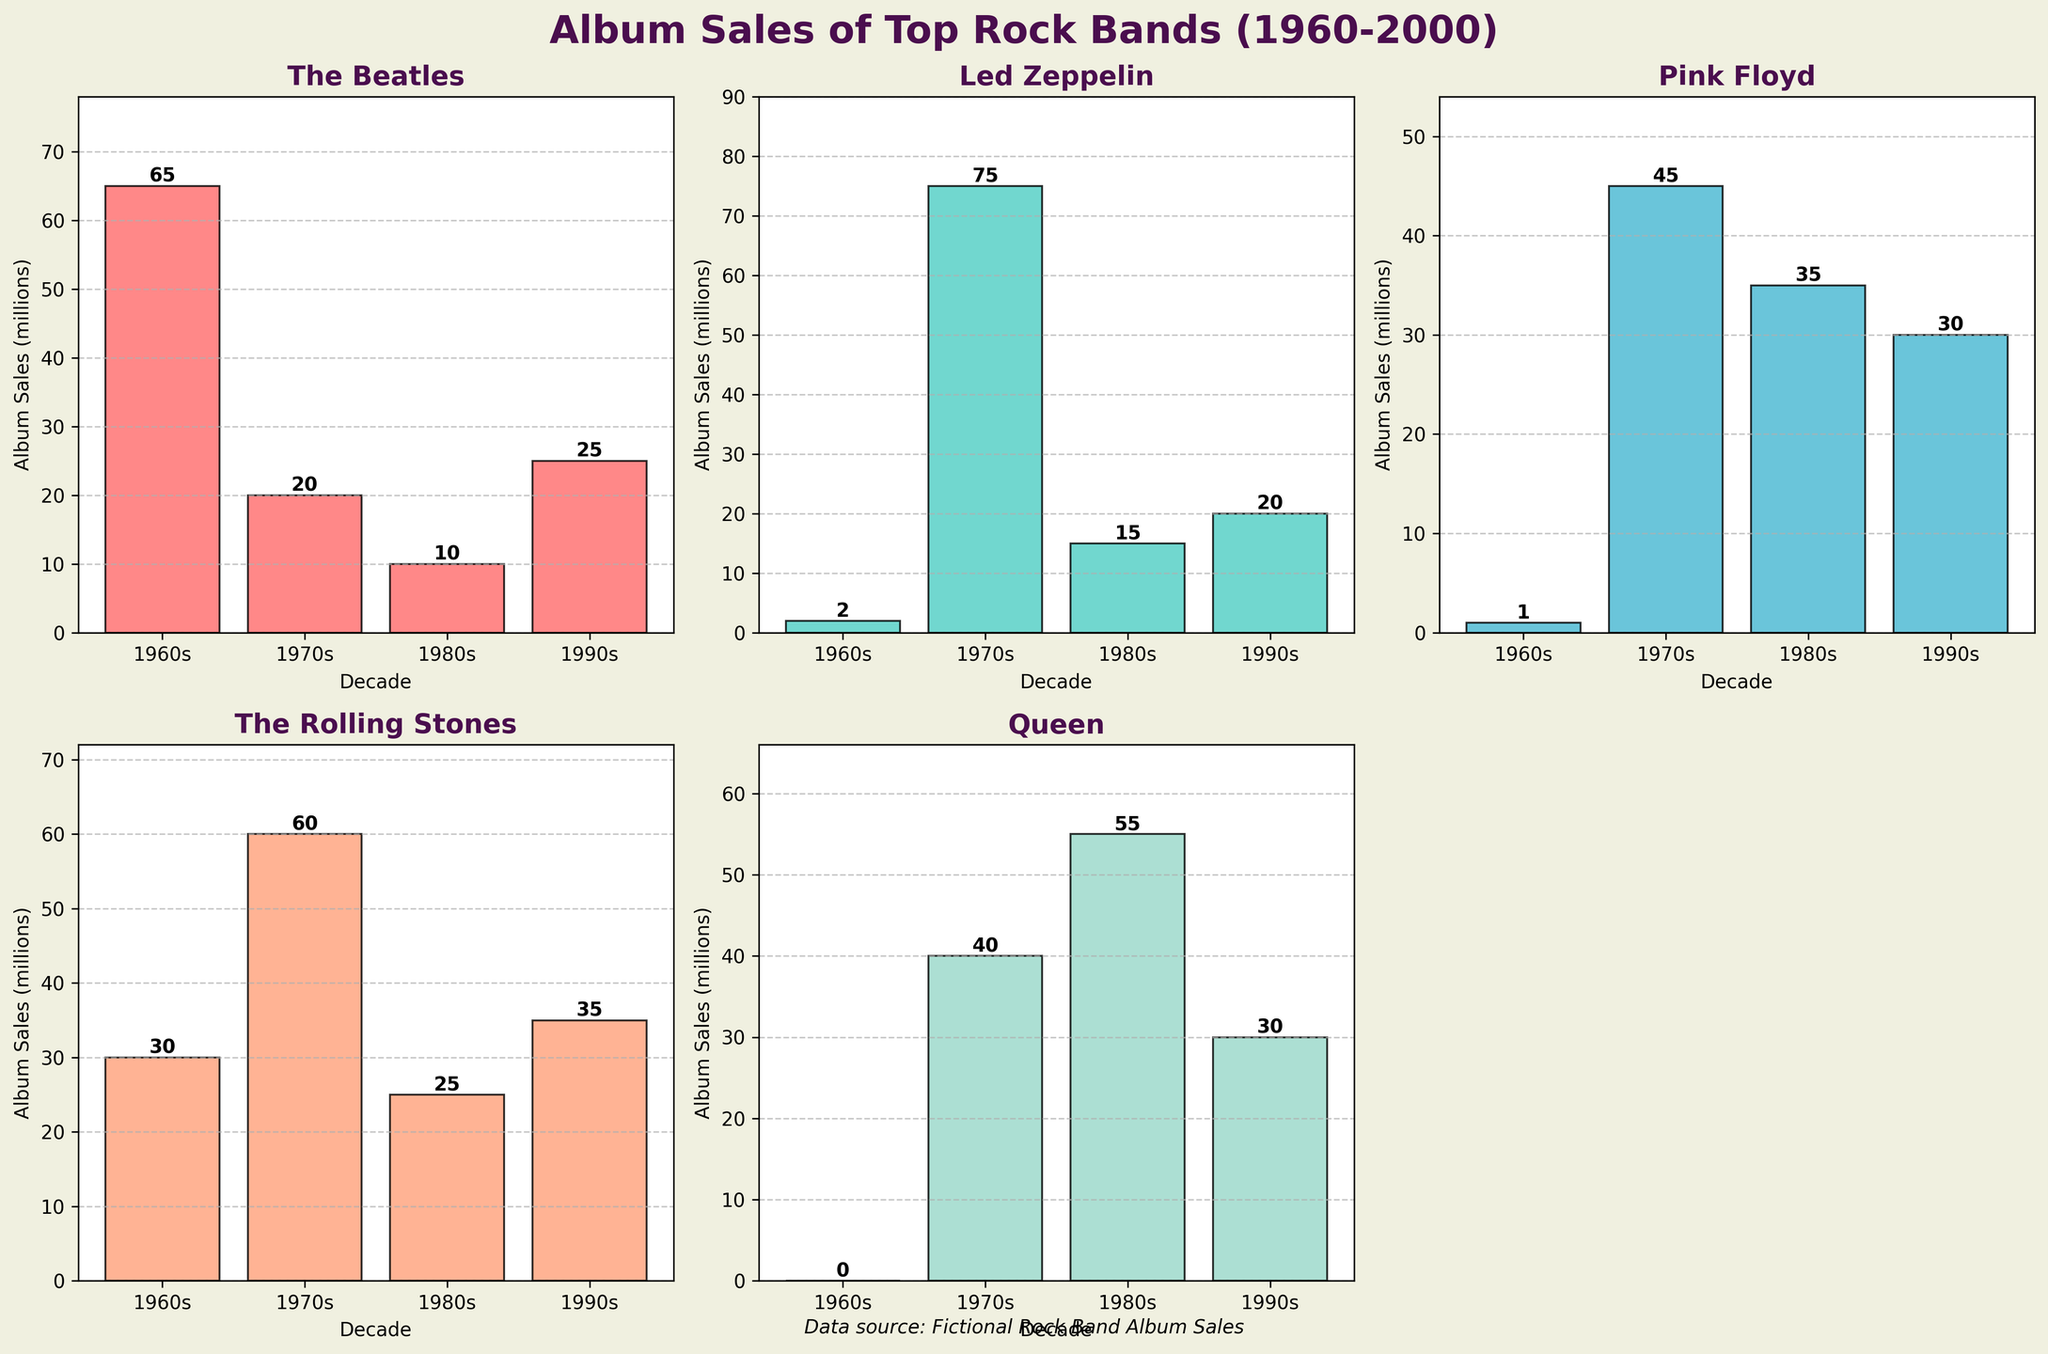What's the title of the plot? The plot's title is given at the top of the figure in a large, bold font. By looking at this area, you can find the title.
Answer: Album Sales of Top Rock Bands (1960-2000) Which band had the highest album sales in the 1970s? By examining the bar heights for the 1970s, you can see the tallest bar corresponds to Led Zeppelin.
Answer: Led Zeppelin How many bands are represented in the figure? There are subplots, each representing a different band. Counting these will give the number of bands.
Answer: 5 Which decades had the highest number of album sales for The Rolling Stones? For each decade, compare the bar heights for The Rolling Stones. The tallest bar will indicate the decade with the highest album sales.
Answer: 1970s What were Pink Floyd's album sales in the 1980s? Locate the subplot for Pink Floyd and check the bar height for the 1980s. The number above the bar shows the album sales in millions.
Answer: 35 What is the sum of album sales for Queen across all decades? Add up Queen's album sales for all decades by adding 0 (1960s) + 40 (1970s) + 55 (1980s) + 30 (1990s).
Answer: 125 In which decade did The Beatles experience a significant drop in album sales? Observe the bar heights for The Beatles across decades and identify where a noticeable decline occurs.
Answer: 1970s Were there any bands without album sales in the 1960s? Check each band's subplot for the 1960s and see if there are any bars of height zero.
Answer: Queen, Led Zeppelin, Pink Floyd How did The Rolling Stones' album sales change from the 1960s to the 1970s? Compare the heights of The Rolling Stones' bars for the 1960s and 1970s and note the difference.
Answer: Increased by 30 million Which band's album sales steadily decreased over the decades? Examine each band's subplots and compare the bar heights across decades to see if any band's sales consistently dropped.
Answer: The Beatles 